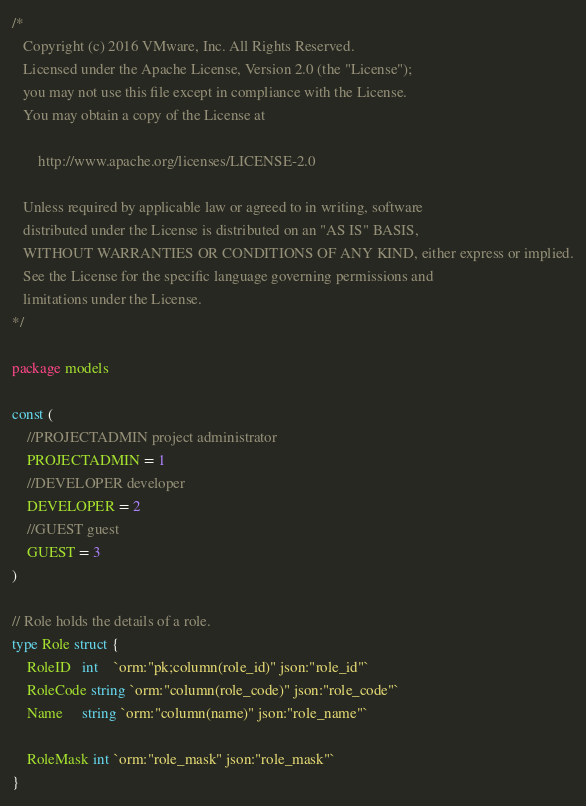<code> <loc_0><loc_0><loc_500><loc_500><_Go_>/*
   Copyright (c) 2016 VMware, Inc. All Rights Reserved.
   Licensed under the Apache License, Version 2.0 (the "License");
   you may not use this file except in compliance with the License.
   You may obtain a copy of the License at

       http://www.apache.org/licenses/LICENSE-2.0

   Unless required by applicable law or agreed to in writing, software
   distributed under the License is distributed on an "AS IS" BASIS,
   WITHOUT WARRANTIES OR CONDITIONS OF ANY KIND, either express or implied.
   See the License for the specific language governing permissions and
   limitations under the License.
*/

package models

const (
	//PROJECTADMIN project administrator
	PROJECTADMIN = 1
	//DEVELOPER developer
	DEVELOPER = 2
	//GUEST guest
	GUEST = 3
)

// Role holds the details of a role.
type Role struct {
	RoleID   int    `orm:"pk;column(role_id)" json:"role_id"`
	RoleCode string `orm:"column(role_code)" json:"role_code"`
	Name     string `orm:"column(name)" json:"role_name"`

	RoleMask int `orm:"role_mask" json:"role_mask"`
}
</code> 